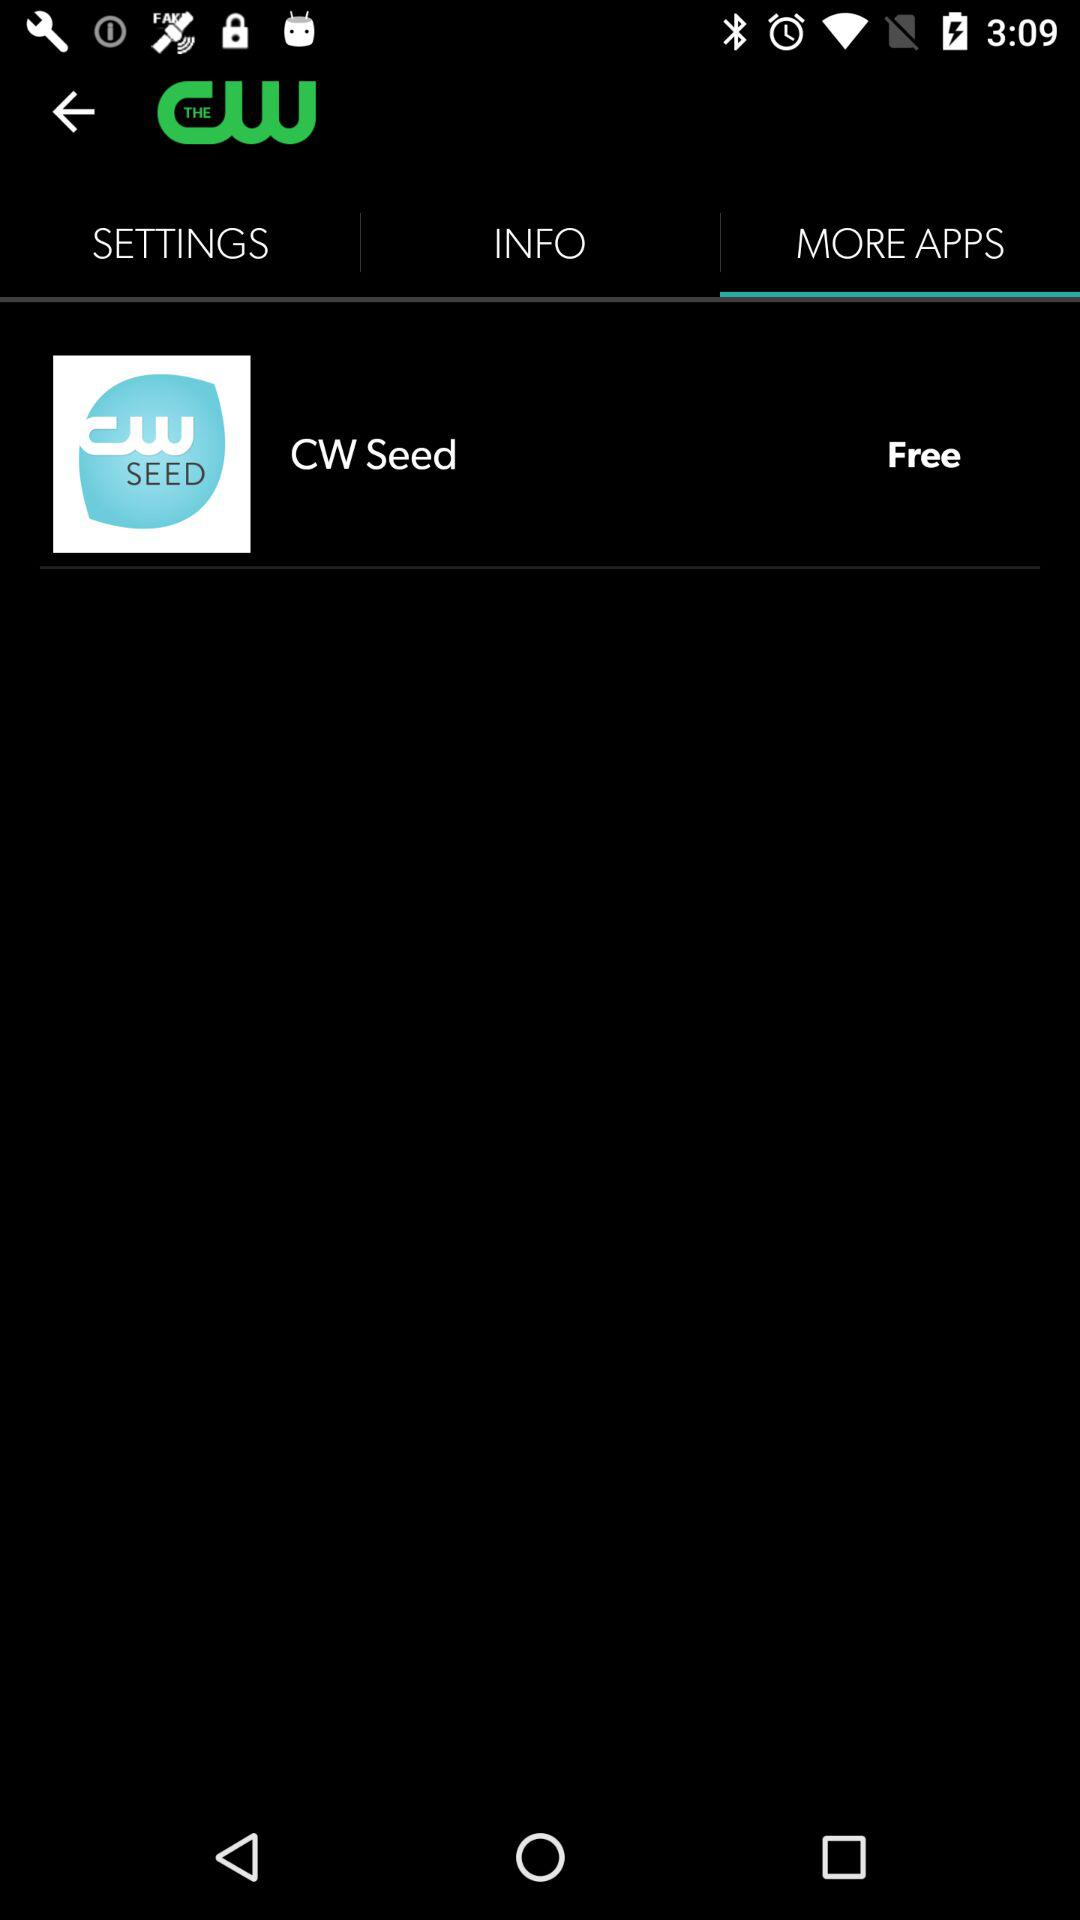Which tab is selected? The selected tab is More Apps. 